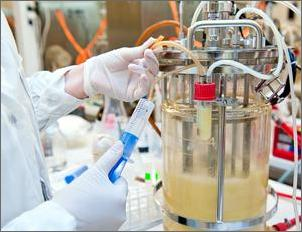Can you describe what is happening in the image and how it might relate to Emilia’s experiment? The image shows a laboratory setting with a scientist working on a bioreactor, which is used for growing cultures, probably bacteria or yeast. This equipment helps maintain precise conditions to optimize microbial growth and production. In relation to Emilia’s experiment, she could be testing the effect of different nutrients or environmental conditions on the production of a specific biochemical product, like insulin, by these microorganisms. 